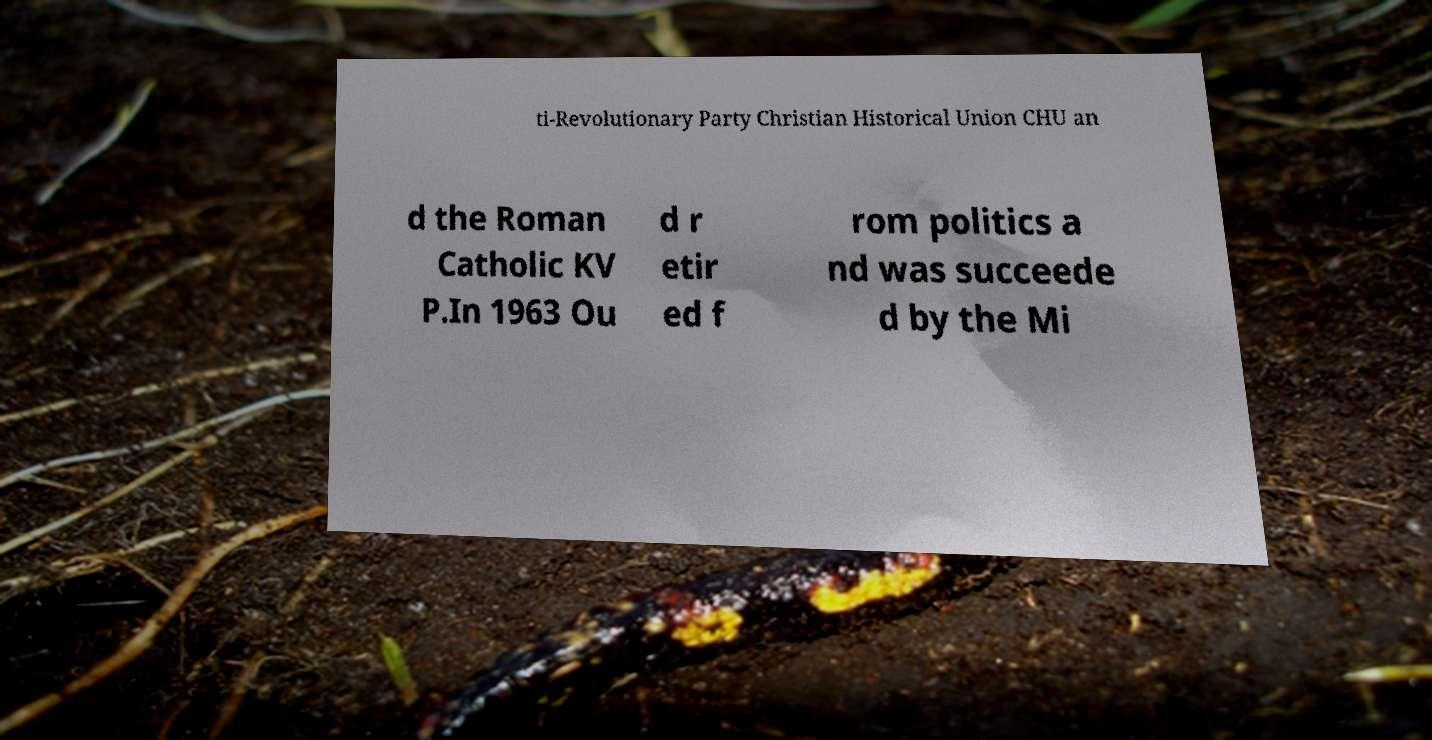For documentation purposes, I need the text within this image transcribed. Could you provide that? ti-Revolutionary Party Christian Historical Union CHU an d the Roman Catholic KV P.In 1963 Ou d r etir ed f rom politics a nd was succeede d by the Mi 